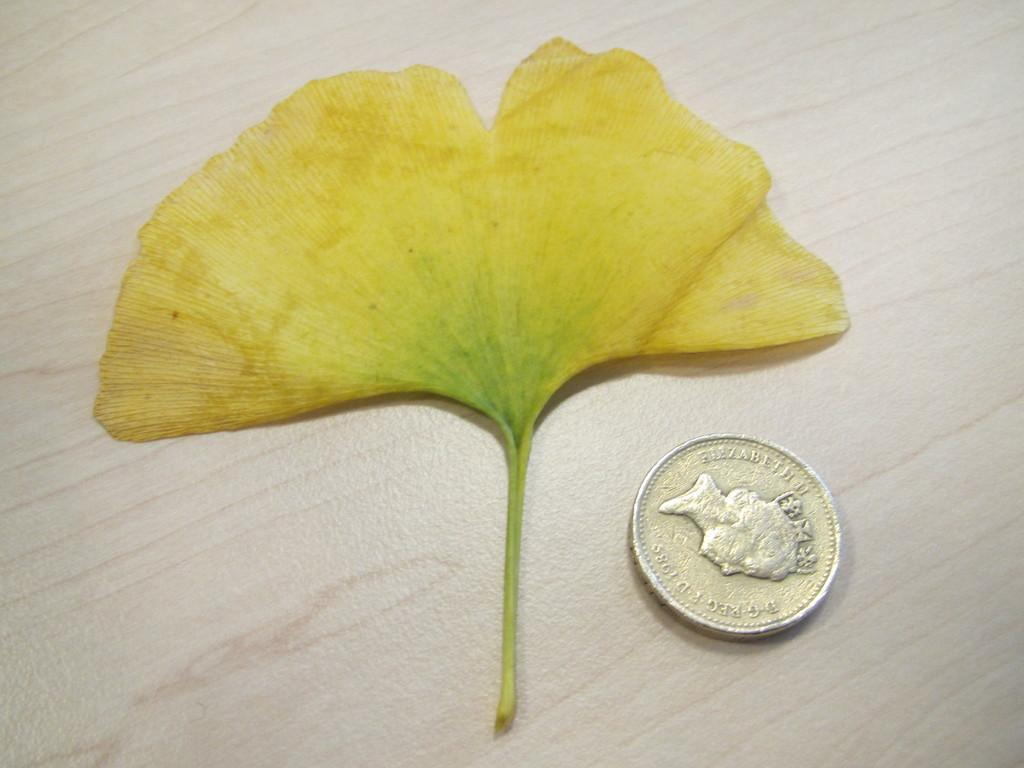What is the main subject of the image? There is a flower in the image. What else can be seen on the table in the image? There is a coin on the table in the image. What is depicted on the coin? The coin has an image of a woman on it. Are there any words or symbols on the coin? Yes, there is text carved on the coin. Can you tell me how many jellyfish are swimming around the flower in the image? There are no jellyfish present in the image; it features a flower and a coin on a table. What type of beetle is crawling on the petals of the flower in the image? There is no beetle present on the flower in the image; it is a single flower with no additional insects or creatures. 